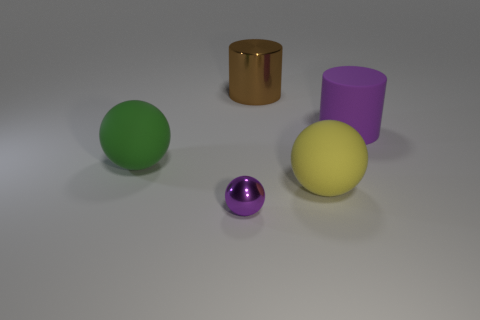Add 1 brown cylinders. How many objects exist? 6 Subtract all large rubber spheres. How many spheres are left? 1 Subtract 1 spheres. How many spheres are left? 2 Subtract all cylinders. How many objects are left? 3 Subtract all gray balls. Subtract all green cylinders. How many balls are left? 3 Subtract all purple objects. Subtract all large brown things. How many objects are left? 2 Add 2 big brown shiny cylinders. How many big brown shiny cylinders are left? 3 Add 2 tiny red rubber objects. How many tiny red rubber objects exist? 2 Subtract 0 cyan blocks. How many objects are left? 5 